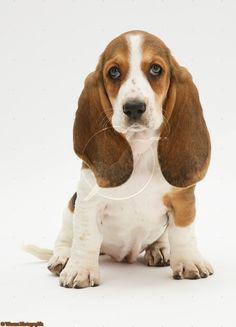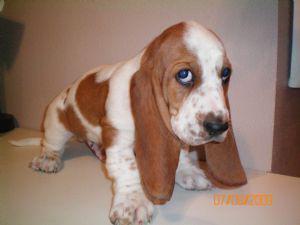The first image is the image on the left, the second image is the image on the right. Assess this claim about the two images: "There is one basset hound sitting and facing forward and one basset hound facing right and glancing sideways.". Correct or not? Answer yes or no. Yes. The first image is the image on the left, the second image is the image on the right. Examine the images to the left and right. Is the description "Both dogs are sitting down." accurate? Answer yes or no. No. 